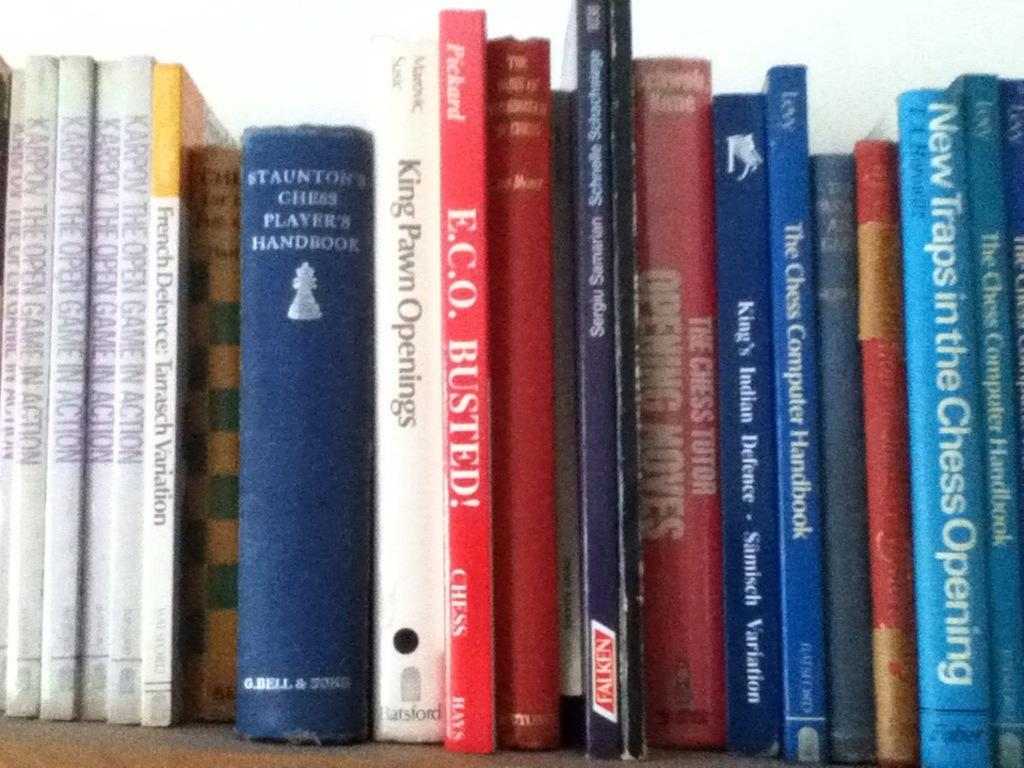What objects can be seen in the image? There are books in the image. Where are the books placed? The books are on a wooden board. What can be read on the books? There is text visible on the books. What type of ghost can be seen interacting with the books in the image? There is no ghost present in the image; it features books on a wooden board with visible text. 